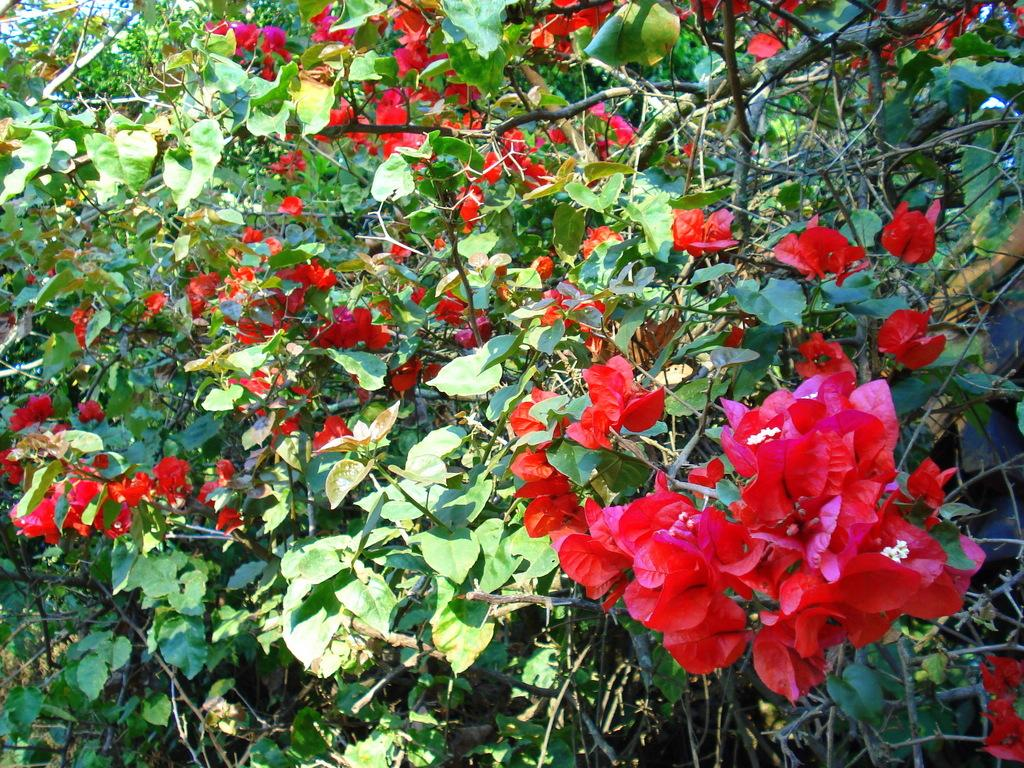Where was the image taken? The image was taken outdoors. What type of vegetation can be seen in the image? There are plants with green leaves in the image. What are the characteristics of the plants in the image? The plants have stems and red-colored flowers in the image. What type of relation do the cats have with the plants in the image? There are no cats present in the image, so it is not possible to determine any relation between cats and the plants. 